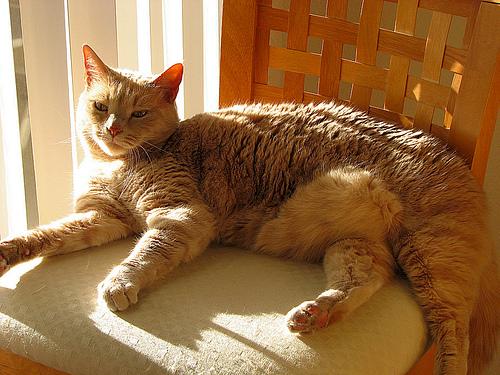Is this cat male or female?
Quick response, please. Male. Is the cat awake?
Concise answer only. Yes. Is it sunny?
Be succinct. Yes. 